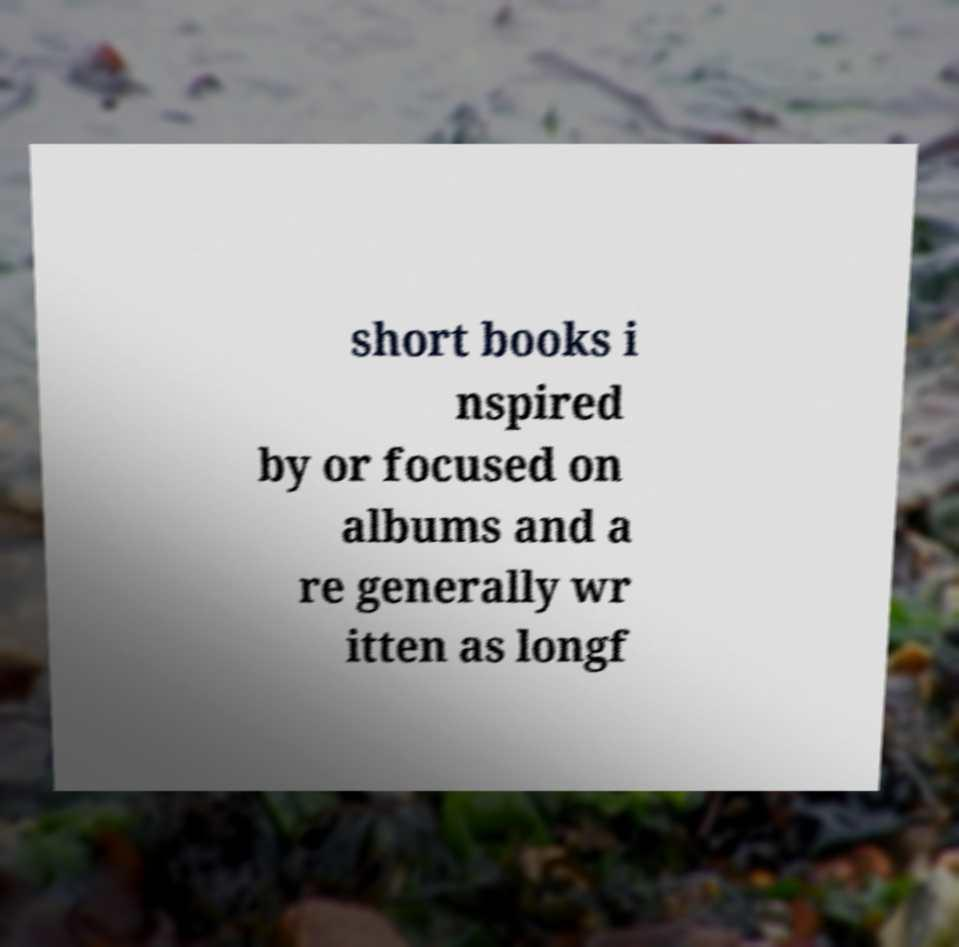There's text embedded in this image that I need extracted. Can you transcribe it verbatim? short books i nspired by or focused on albums and a re generally wr itten as longf 